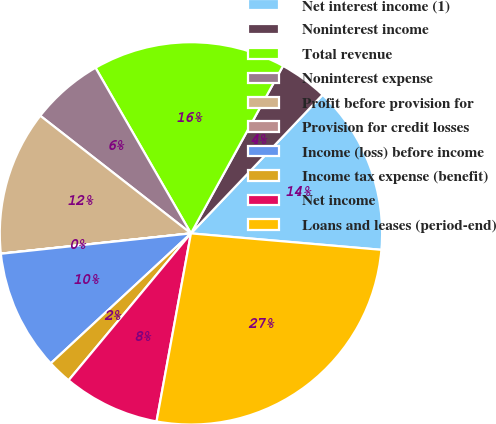Convert chart to OTSL. <chart><loc_0><loc_0><loc_500><loc_500><pie_chart><fcel>Net interest income (1)<fcel>Noninterest income<fcel>Total revenue<fcel>Noninterest expense<fcel>Profit before provision for<fcel>Provision for credit losses<fcel>Income (loss) before income<fcel>Income tax expense (benefit)<fcel>Net income<fcel>Loans and leases (period-end)<nl><fcel>14.28%<fcel>4.09%<fcel>16.32%<fcel>6.13%<fcel>12.24%<fcel>0.01%<fcel>10.2%<fcel>2.05%<fcel>8.17%<fcel>26.51%<nl></chart> 